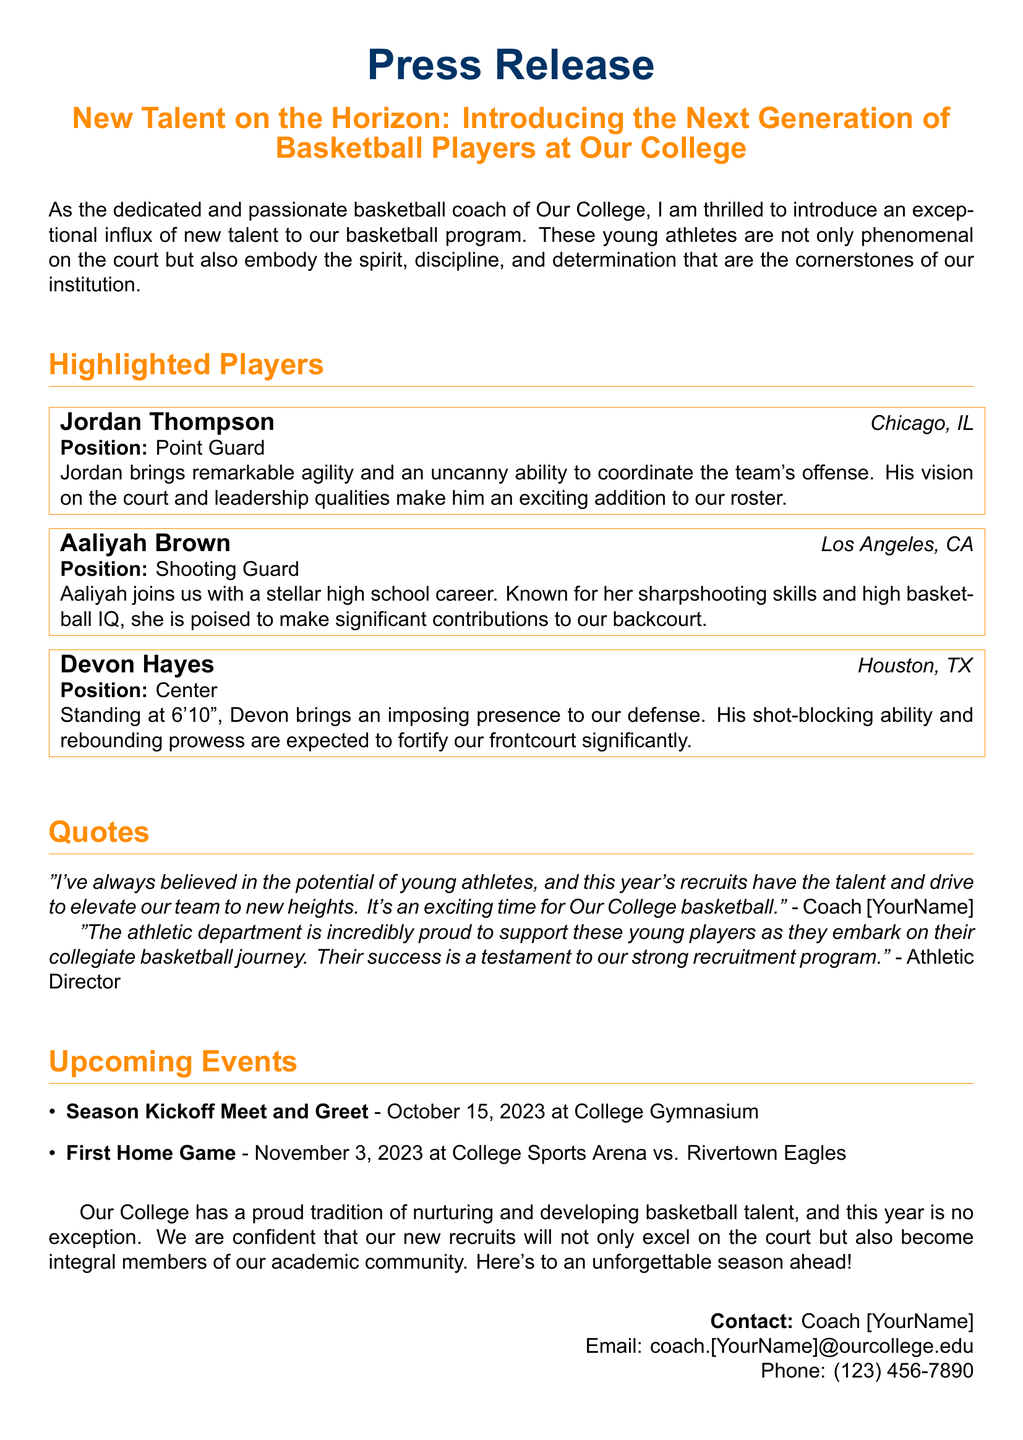What is the title of the press release? The title of the press release introduces the new talent and gives the overall theme of the document.
Answer: New Talent on the Horizon: Introducing the Next Generation of Basketball Players at Our College Who is the first highlighted player? The document lists players in a specific order, starting with Jordan Thompson.
Answer: Jordan Thompson What position does Aaliyah Brown play? The document specifies the positions of highlighted players, identifying Aaliyah's role.
Answer: Shooting Guard What is Devon Hayes's height? The document mentions Devon Hayes's height, which is crucial for his position as a Center.
Answer: 6'10" When is the first home game scheduled? The document provides a specific date for the first home game, which is important for fans and supporters.
Answer: November 3, 2023 Who made a quote about the potential of young athletes? The quotes section of the document includes statements from the coach and the athletic director, highlighting their perspectives.
Answer: Coach [YourName] What event occurs on October 15, 2023? The document outlines upcoming events, including a specific meet and greet date for fans and players.
Answer: Season Kickoff Meet and Greet What color is used for the header text? The document describes specific design aspects, including colors used for the title and headers.
Answer: basketballorange 